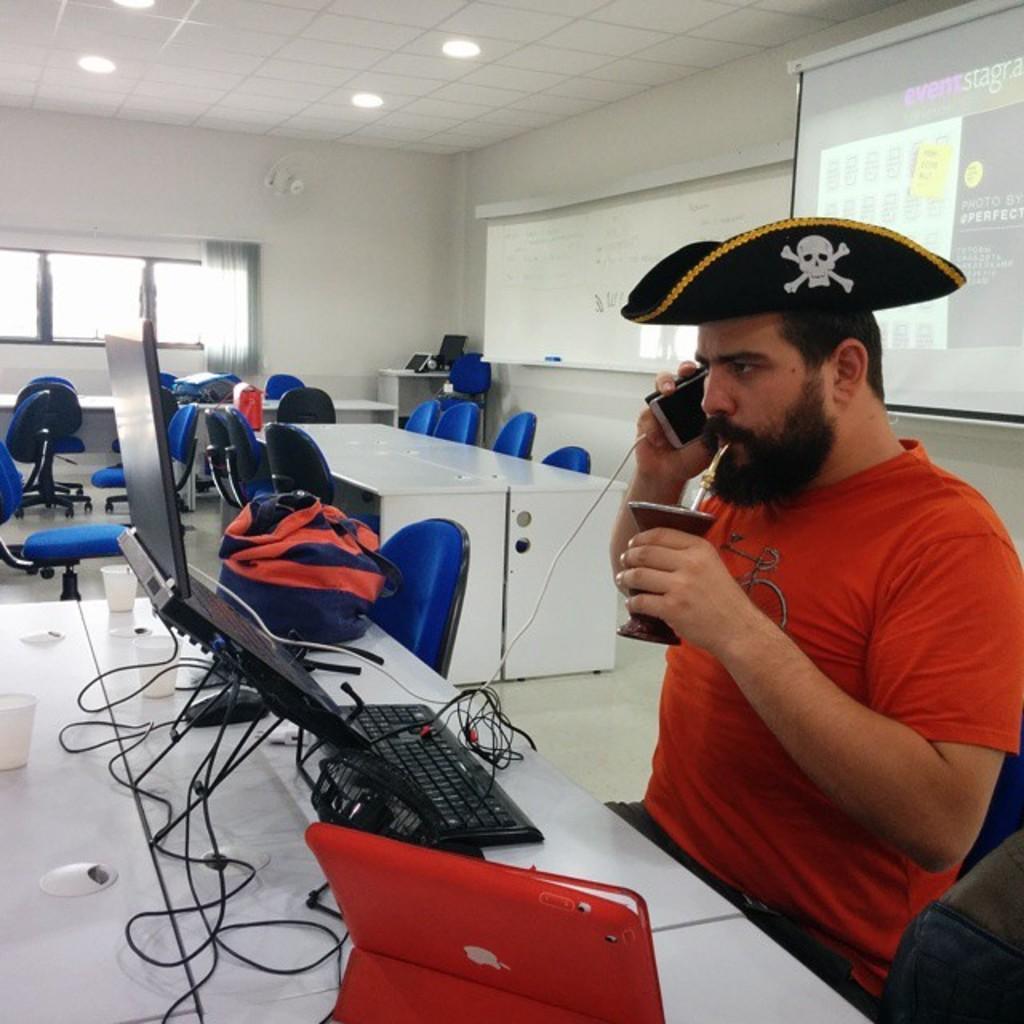Please provide a concise description of this image. In this image I can see a person sitting in-front of the system and he is the holding a mobile. In the background there are lights and a window. 